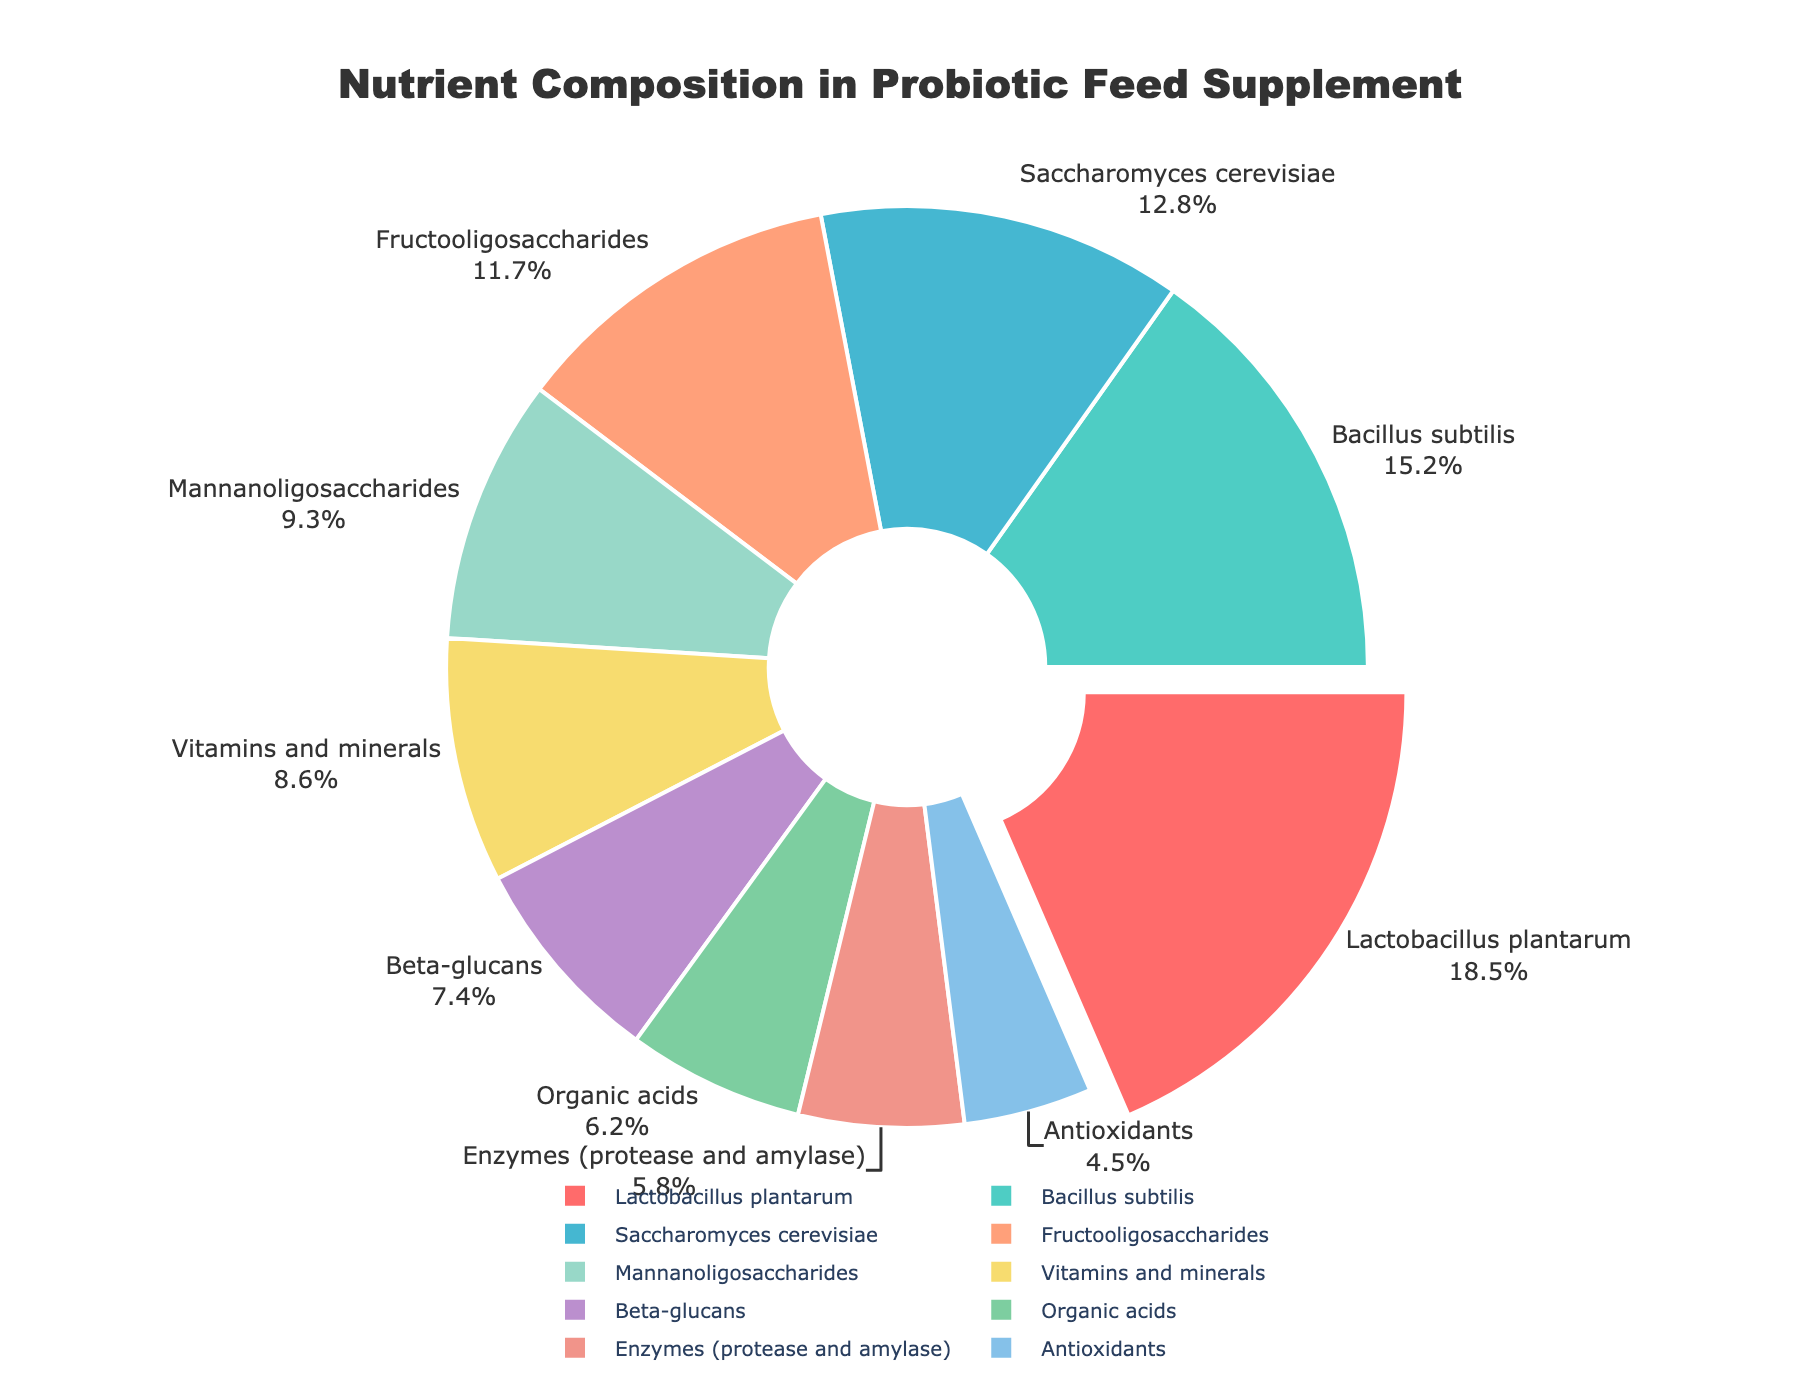Which nutrient has the highest composition percentage in the feed supplement? The pie chart highlights the nutrient with the highest percentage by pulling it out slightly from the rest. The data shows that Lactobacillus plantarum has the largest segment.
Answer: Lactobacillus plantarum What is the total percentage of Bacillus subtilis and Saccharomyces cerevisiae? Bacillus subtilis has a percentage of 15.2%, and Saccharomyces cerevisiae has a percentage of 12.8%. Adding these together gives us 15.2 + 12.8 = 28.0%.
Answer: 28.0% Which nutrients combined make up more than 25% of the total composition? Saccharomyces cerevisiae (12.8%) and Lactobacillus plantarum (18.5%) each make up a significant portion. Adding these gives 12.8 + 18.5 = 31.3%, which is more than 25%.
Answer: Saccharomyces cerevisiae, Lactobacillus plantarum Is the proportion of Fructooligosaccharides greater than Mannanoligosaccharides? Fructooligosaccharides make up 11.7% of the chart, while Mannanoligosaccharides make up 9.3%. Comparing these values, 11.7 is greater than 9.3.
Answer: Yes What is the percentage difference between Vitamins and minerals and Beta-glucans? Vitamins and minerals are 8.6%, and Beta-glucans are 7.4%. The difference is found by subtracting the smaller percentage from the larger one: 8.6 - 7.4 = 1.2%.
Answer: 1.2% Which nutrient has the smallest percentage, and what is its value? Observing the segments of the pie chart, Antioxidants have the smallest segment, with a percentage value of 4.5%.
Answer: Antioxidants, 4.5% How does the composition of Organic acids compare to Enzymes (protease and amylase)? Organic acids have a 6.2% composition, whereas Enzymes (protease and amylase) have a 5.8% composition. Comparing these values, 6.2 is slightly greater than 5.8.
Answer: Organic acids > Enzymes Which three nutrients individually contribute the least to the total composition? The chart segments with the smallest percentages are Antioxidants (4.5%), Enzymes (protease and amylase) (5.8%), and Organic acids (6.2%).
Answer: Antioxidants, Enzymes (protease and amylase), Organic acids What is the combined percentage of nutrients contributing less than 10% each? The relevant nutrients are: Mannanoligosaccharides (9.3%), Vitamins and minerals (8.6%), Beta-glucans (7.4%), Organic acids (6.2%), Enzymes (protease and amylase) (5.8%), and Antioxidants (4.5%). Adding these together: 9.3 + 8.6 + 7.4 + 6.2 + 5.8 + 4.5 = 41.8%.
Answer: 41.8% 